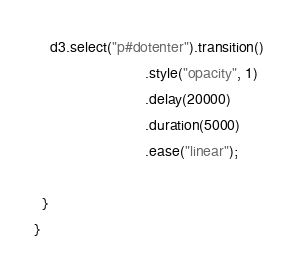<code> <loc_0><loc_0><loc_500><loc_500><_JavaScript_>    d3.select("p#dotenter").transition()
                           .style("opacity", 1)
                           .delay(20000)
                           .duration(5000)
                           .ease("linear");

  }
}
</code> 